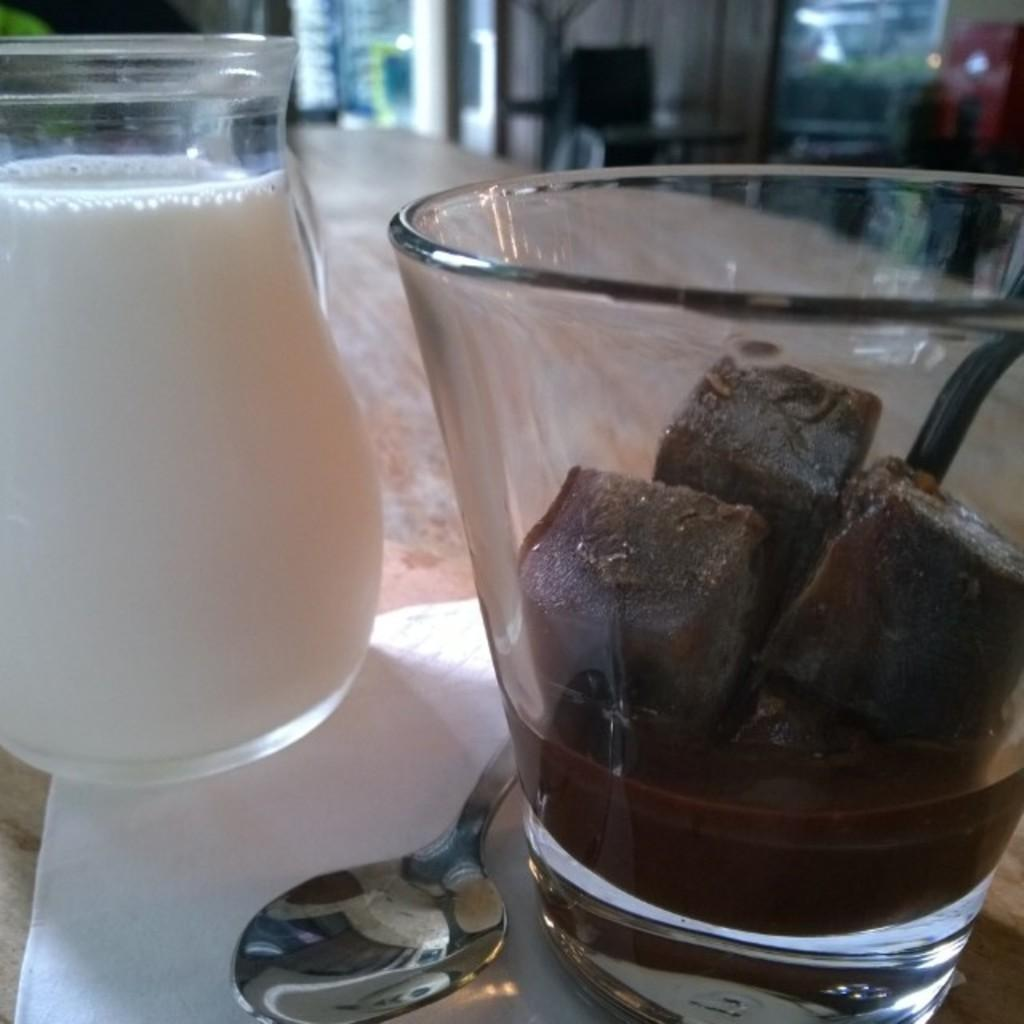What is on the table in the image? There is a milk jar, a glass, a spoon, and tissue paper on the table. What is inside the glass? Ice cubes are visible in the glass. What can be seen in the background of the image? There are windows and tables in the background. Where is the cannon located in the image? There is no cannon present in the image. What type of flag is visible in the image? There is no flag present in the image. 